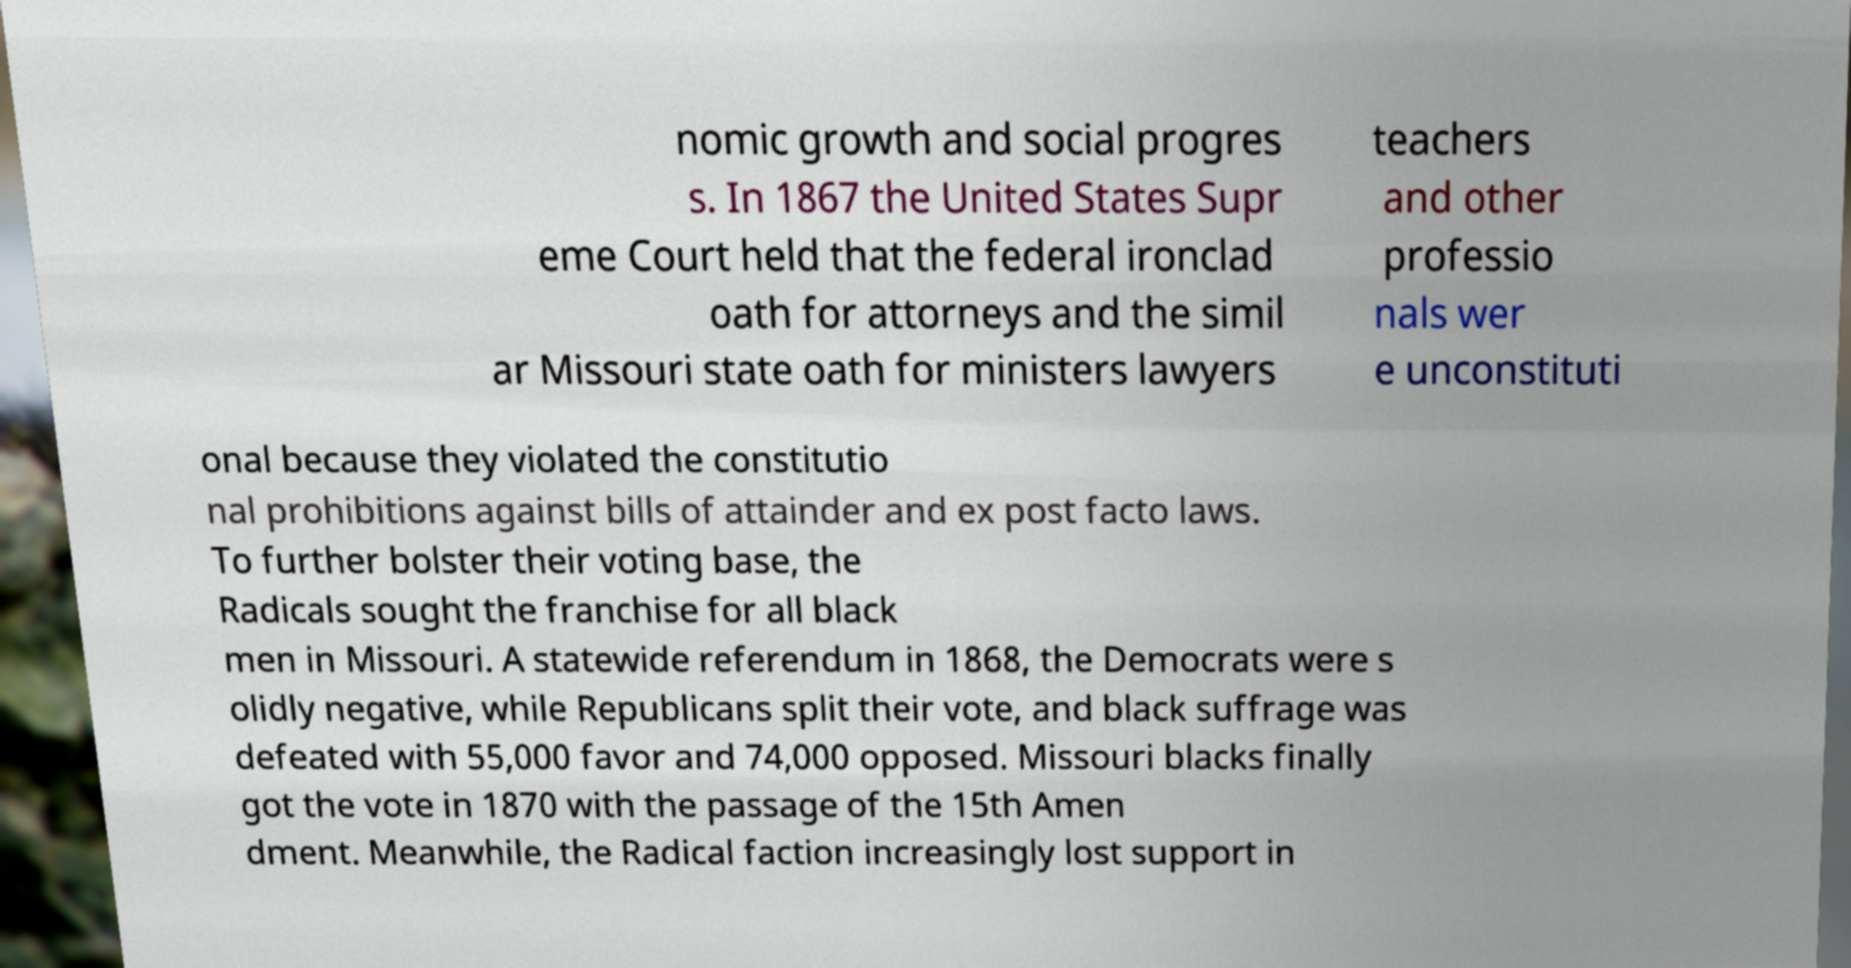There's text embedded in this image that I need extracted. Can you transcribe it verbatim? nomic growth and social progres s. In 1867 the United States Supr eme Court held that the federal ironclad oath for attorneys and the simil ar Missouri state oath for ministers lawyers teachers and other professio nals wer e unconstituti onal because they violated the constitutio nal prohibitions against bills of attainder and ex post facto laws. To further bolster their voting base, the Radicals sought the franchise for all black men in Missouri. A statewide referendum in 1868, the Democrats were s olidly negative, while Republicans split their vote, and black suffrage was defeated with 55,000 favor and 74,000 opposed. Missouri blacks finally got the vote in 1870 with the passage of the 15th Amen dment. Meanwhile, the Radical faction increasingly lost support in 